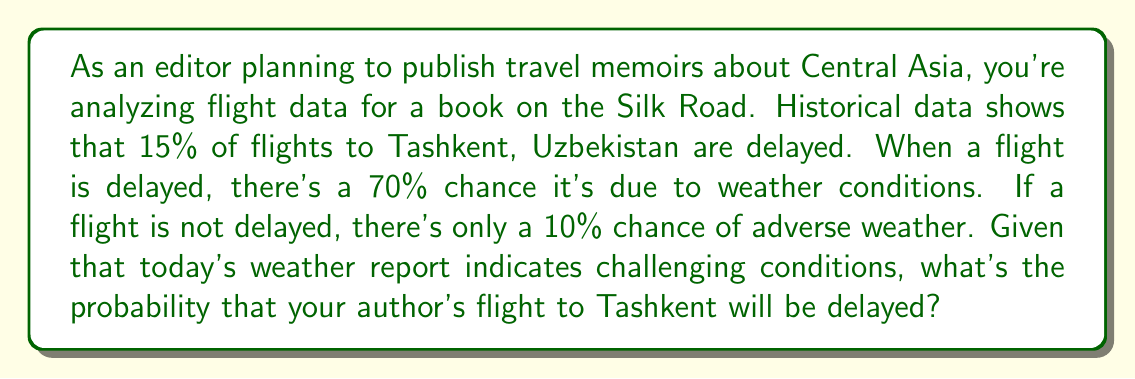Solve this math problem. Let's approach this using Bayes' theorem:

1) Define our events:
   D: Flight is delayed
   W: Weather is adverse

2) Given probabilities:
   P(D) = 0.15 (probability of delay)
   P(W|D) = 0.70 (probability of adverse weather given delay)
   P(W|not D) = 0.10 (probability of adverse weather given no delay)
   We know W has occurred (today's weather is adverse)

3) We want to find P(D|W) using Bayes' theorem:

   $$P(D|W) = \frac{P(W|D) \cdot P(D)}{P(W)}$$

4) We need to calculate P(W):
   $$P(W) = P(W|D) \cdot P(D) + P(W|not D) \cdot P(not D)$$
   $$P(W) = 0.70 \cdot 0.15 + 0.10 \cdot 0.85$$
   $$P(W) = 0.105 + 0.085 = 0.19$$

5) Now we can apply Bayes' theorem:
   $$P(D|W) = \frac{0.70 \cdot 0.15}{0.19}$$
   $$P(D|W) = \frac{0.105}{0.19} \approx 0.5526$$

6) Convert to percentage:
   0.5526 * 100 ≈ 55.26%
Answer: 55.26% 